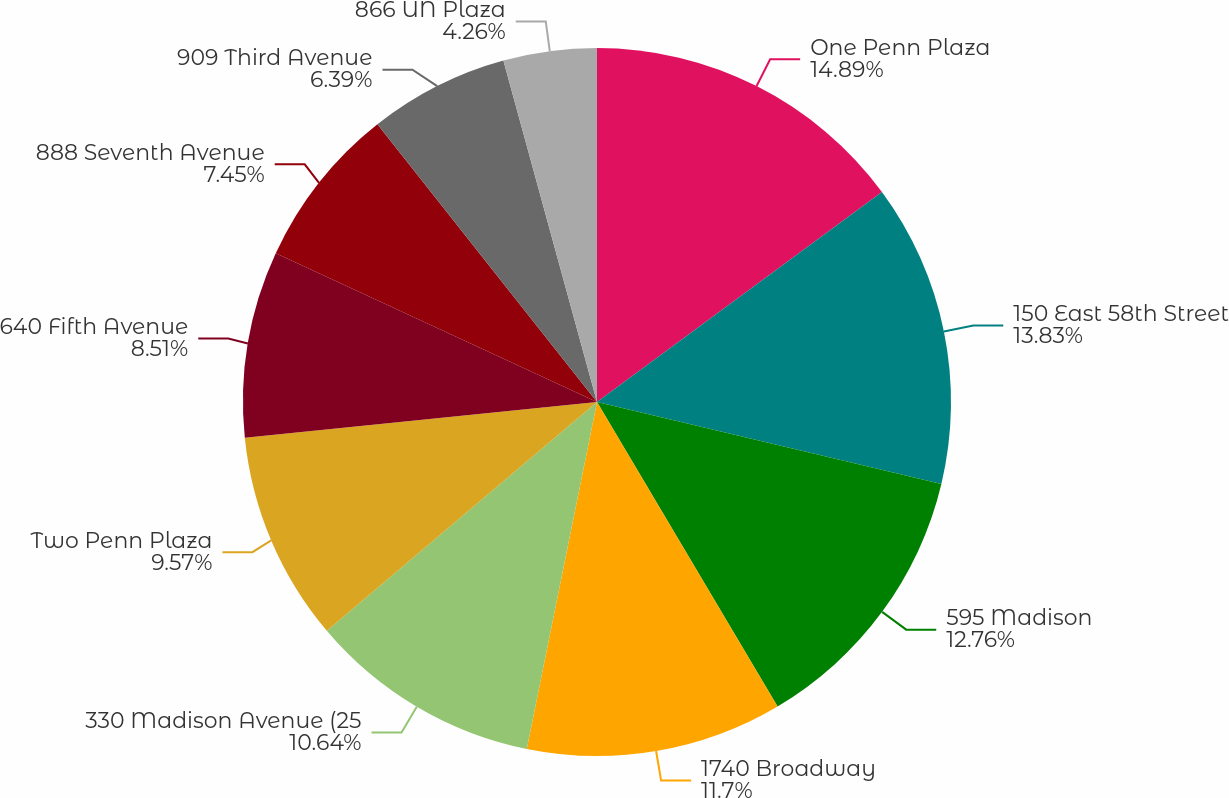Convert chart to OTSL. <chart><loc_0><loc_0><loc_500><loc_500><pie_chart><fcel>One Penn Plaza<fcel>150 East 58th Street<fcel>595 Madison<fcel>1740 Broadway<fcel>330 Madison Avenue (25<fcel>Two Penn Plaza<fcel>640 Fifth Avenue<fcel>888 Seventh Avenue<fcel>909 Third Avenue<fcel>866 UN Plaza<nl><fcel>14.89%<fcel>13.83%<fcel>12.76%<fcel>11.7%<fcel>10.64%<fcel>9.57%<fcel>8.51%<fcel>7.45%<fcel>6.39%<fcel>4.26%<nl></chart> 